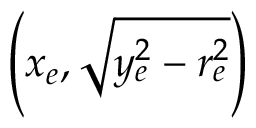<formula> <loc_0><loc_0><loc_500><loc_500>\left ( x _ { e } , { \sqrt { y _ { e } ^ { 2 } - r _ { e } ^ { 2 } } } \right )</formula> 